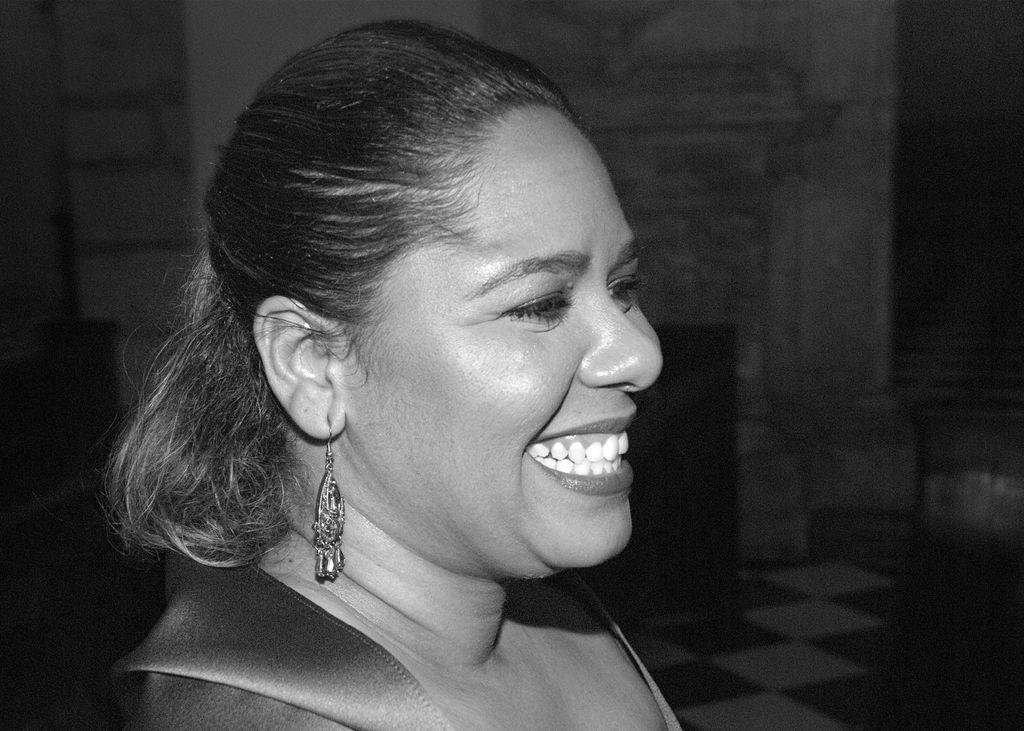Who is the main subject in the image? There is a lady in the center of the image. What can be seen in the background of the image? There is a wall in the background of the image. What time of day is it in the image, and how can you tell? The time of day cannot be determined from the image, as there are no clues such as shadows or lighting to indicate morning or any other time. 